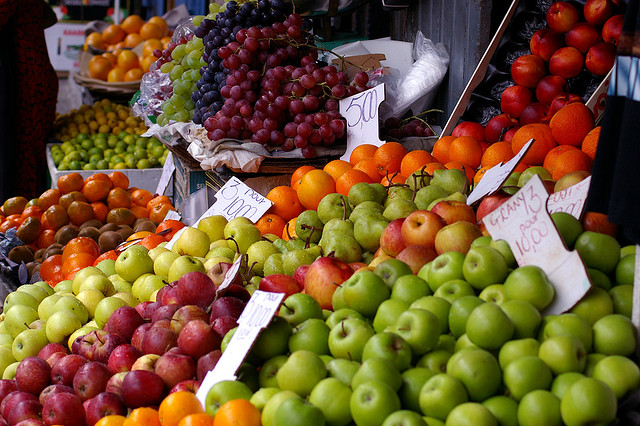Please transcribe the text information in this image. 500 3 in 10,00 13 